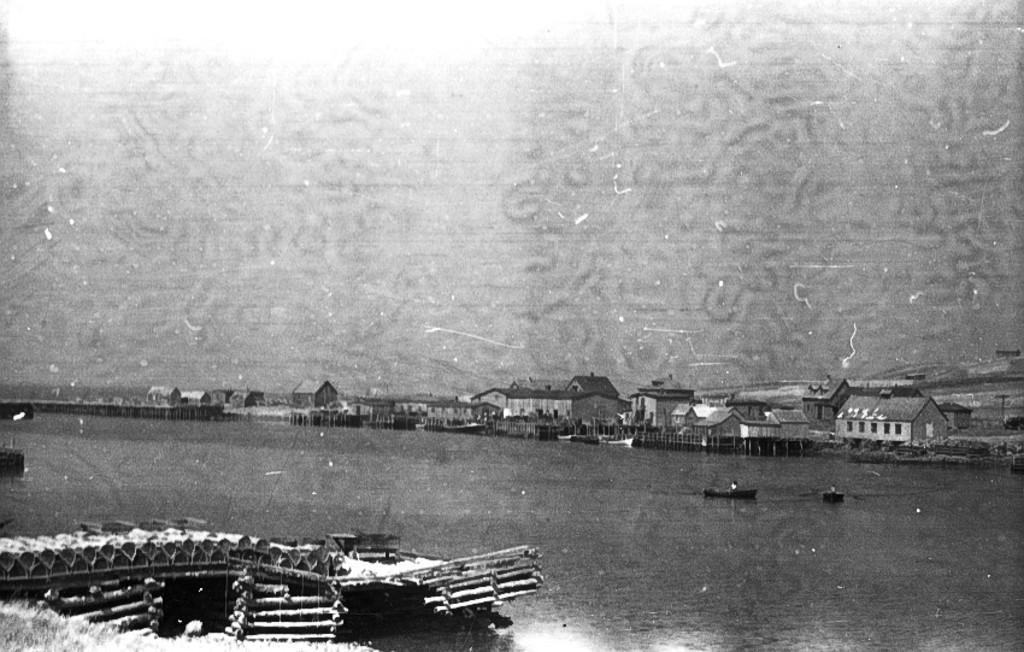Please provide a concise description of this image. This is a black and white picture. Here we can see houses, fence, a wooden bridge. There are boats on the water. 